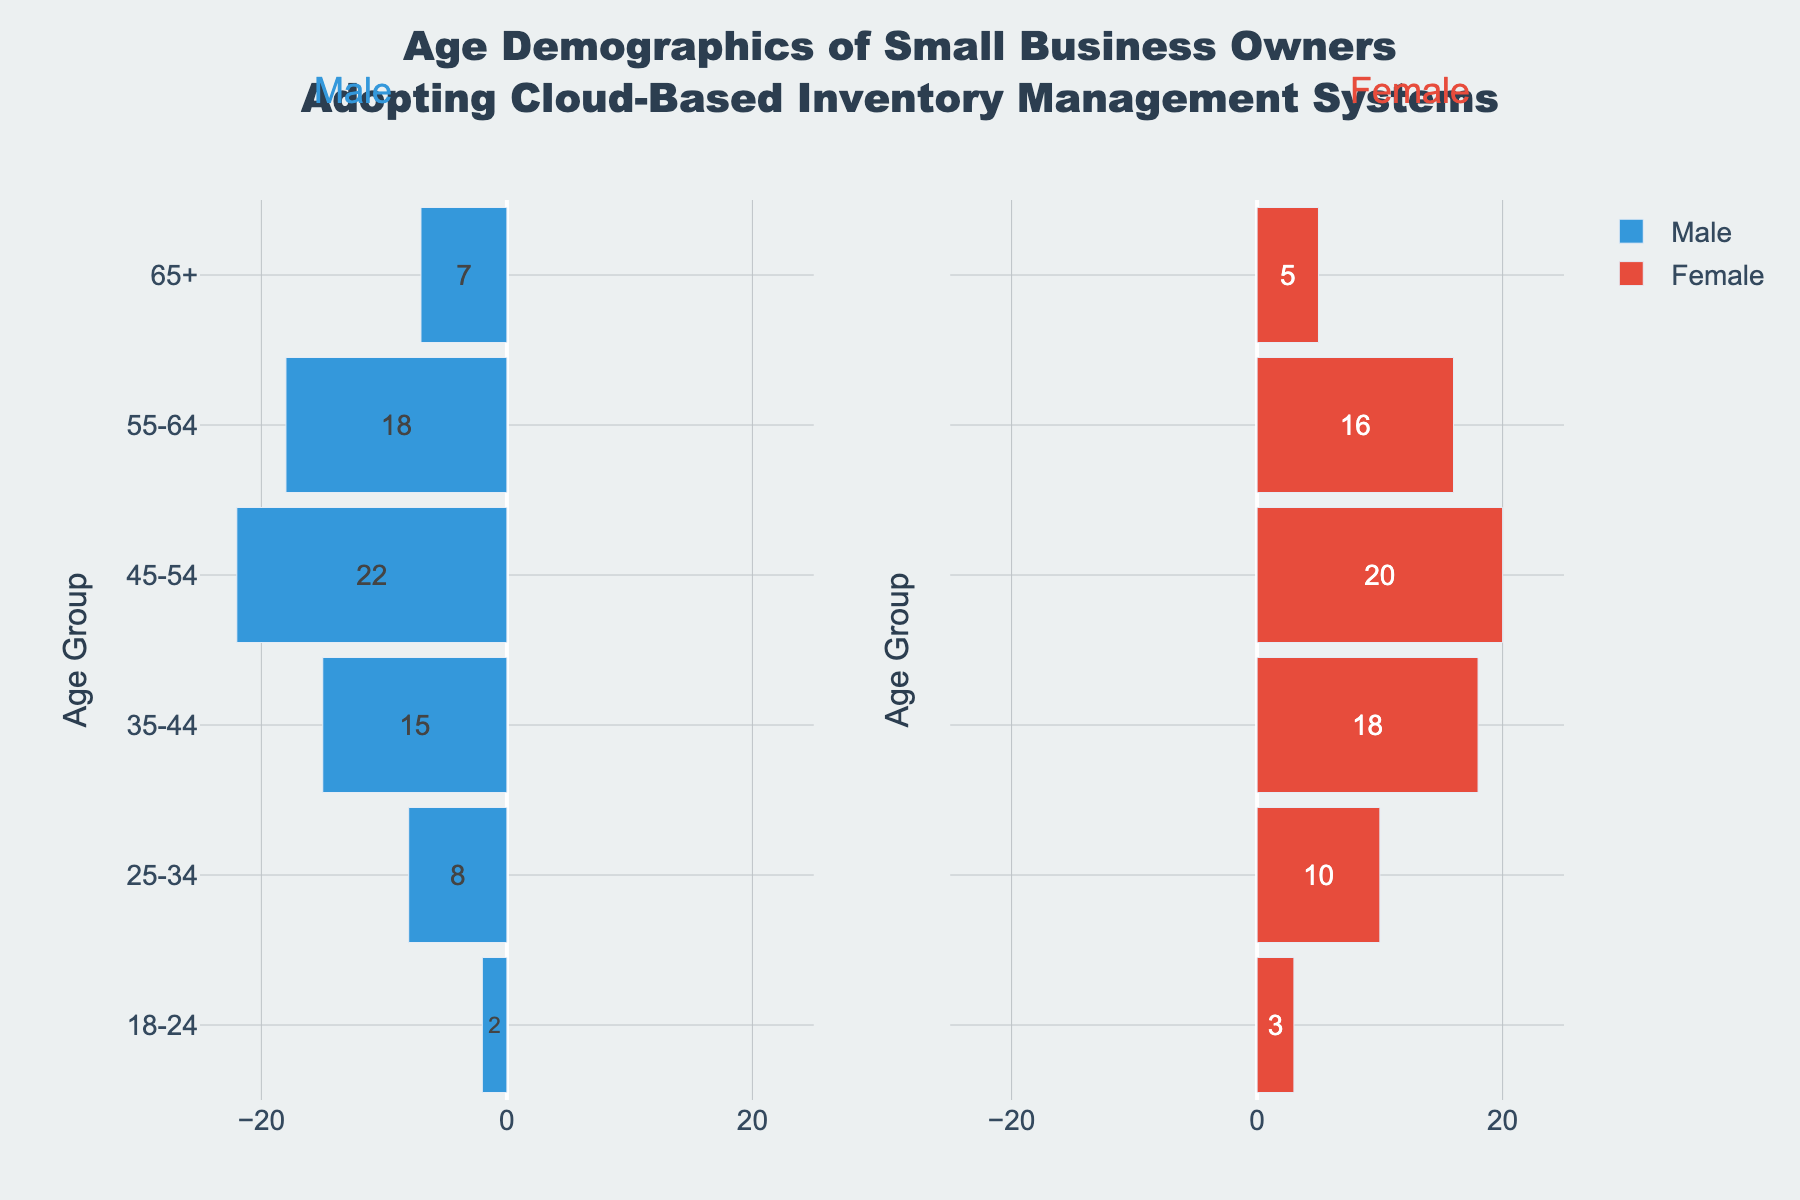Which age group has the highest number of male business owners? The group with the highest number of male business owners is identified by the length of the blue bar extending furthest to the left, indicating the most negative value. The age group "45-54" has the longest leftward bar.
Answer: 45-54 Which age group has the lowest number of female business owners? The group with the lowest number of female business owners can be identified by the shortest red bar on the right. The age group "65+" has the shortest rightward bar.
Answer: 65+ What is the difference in the number of male business owners between the age groups 35-44 and 55-64? To find this difference, we need to subtract the number of male business owners in the "55-64" age group (18) from the "35-44" age group (15), which means the calculation is 18 - 15.
Answer: 3 What is the total number of female business owners aged 25-34 and 35-44? To find the total, add the number of female business owners in the 25-34 age group (10) and the number of female business owners in the 35-44 age group (18). Thus, the calculation is 10 + 18.
Answer: 28 Which age group shows a larger female-to-male ratio, 18-24 or 65+? First, compute the ratio for each group: 
For 18-24, Female = 3, Male = 2, ratio = 3/2 = 1.5 
For 65+, Female = 5, Male = 7, ratio = 5/7 ≈ 0.71.
Comparing these ratios, the "18-24" group has a higher ratio.
Answer: 18-24 Are there more female business owners in the age group 45-54 than the combined number of male and female business owners in the age group 18-24? First, count the females in 45-54 (20), then sum male and female in 18-24 (2 + 3 = 5). Comparing these two, 20 (45-54 females) is greater than 5 (combined 18-24).
Answer: Yes What percentage of the total business owners aged 45-54 are male? First, find the total number of business owners in the 45-54 age group (22 male + 20 female = 42). Then, calculate the percentage of males (22/42 * 100 ≈ 52.38%).
Answer: 52.38% What is the combined percentage of business owners in the 55-64 age group compared to the total number of business owners across all age groups? Calculate the total number of business owners and the combined number in the 55-64 age group. Total across all age groups: (2+8+15+22+18+7) + (3+10+18+20+16+5) = 57 + 72 = 129. In the 55-64 age group: (18+16) = 34. Therefore, the percentage is (34/129 * 100 ≈ 26.36%).
Answer: 26.36% 